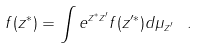Convert formula to latex. <formula><loc_0><loc_0><loc_500><loc_500>f ( z ^ { \ast } ) = \int e ^ { z ^ { \ast } z ^ { \prime } } f ( z ^ { \prime \ast } ) d \mu _ { z ^ { \prime } } \, \ .</formula> 